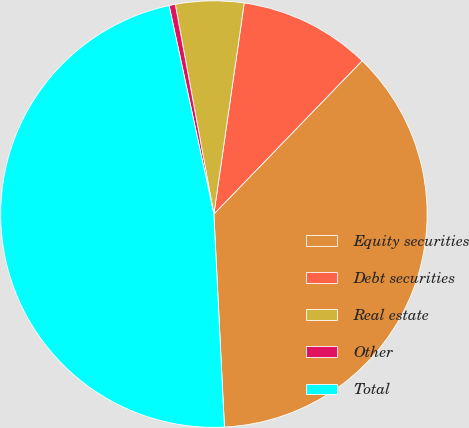Convert chart. <chart><loc_0><loc_0><loc_500><loc_500><pie_chart><fcel>Equity securities<fcel>Debt securities<fcel>Real estate<fcel>Other<fcel>Total<nl><fcel>36.98%<fcel>9.96%<fcel>5.17%<fcel>0.47%<fcel>47.42%<nl></chart> 